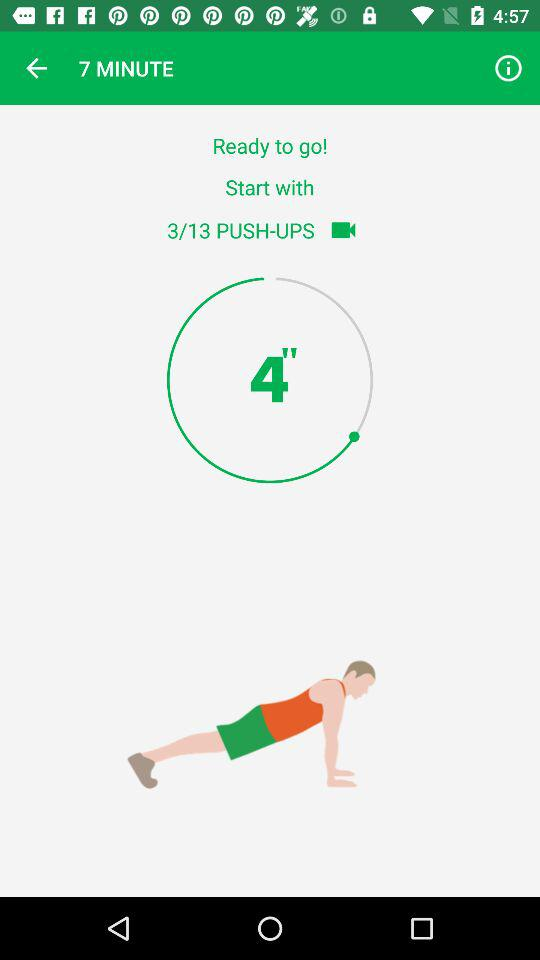What is the current pushup number? The current pushup number is 3. 